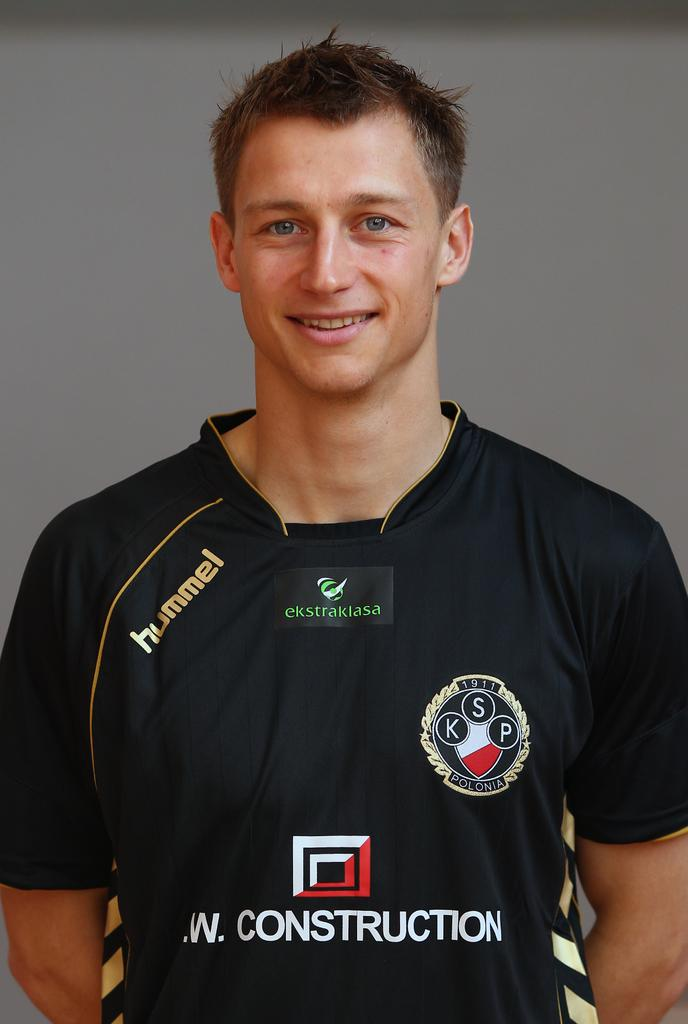<image>
Present a compact description of the photo's key features. a man wearing a shirt that says '.w. construction' 